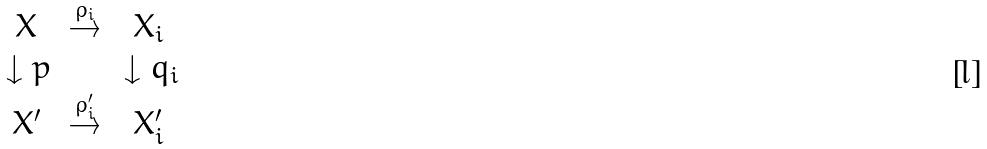Convert formula to latex. <formula><loc_0><loc_0><loc_500><loc_500>\begin{array} { c c c } X & \overset { \rho _ { i } } { \rightarrow } & X _ { i } \\ \, \downarrow p & & \, \downarrow q _ { i } \\ X ^ { \prime } & \overset { \rho _ { i } ^ { \prime } } { \rightarrow } & X _ { i } ^ { \prime } \end{array}</formula> 